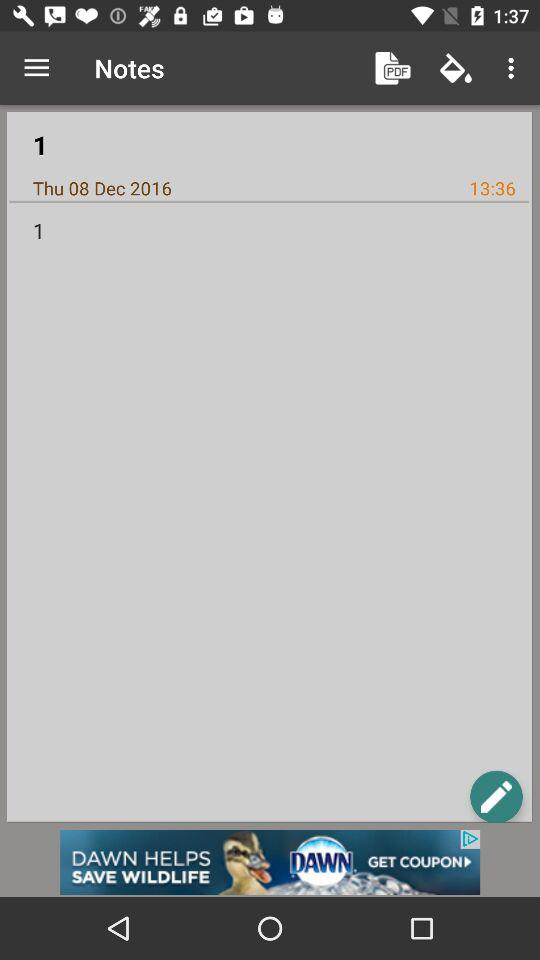At what time was the note saved? The note was saved at 13:36. 